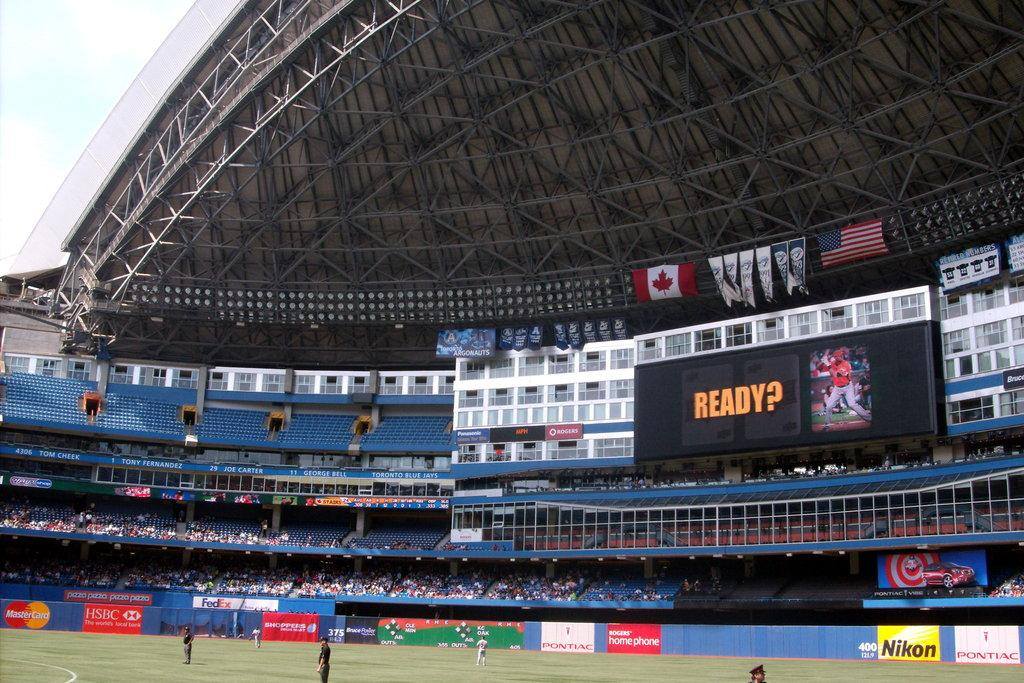<image>
Create a compact narrative representing the image presented. Sports stadium with the word "ready?" on the scoreboard. 